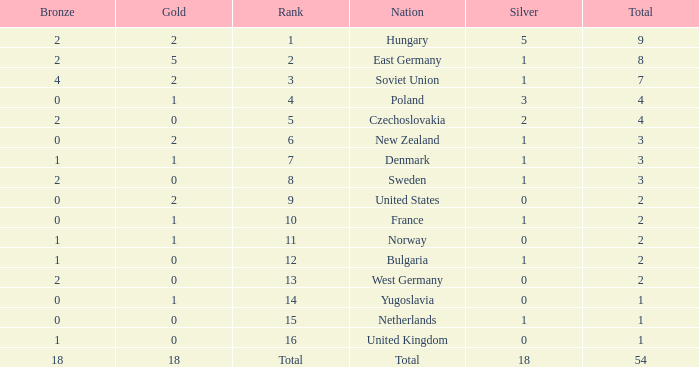What is the lowest total for those receiving less than 18 but more than 14? 1.0. 